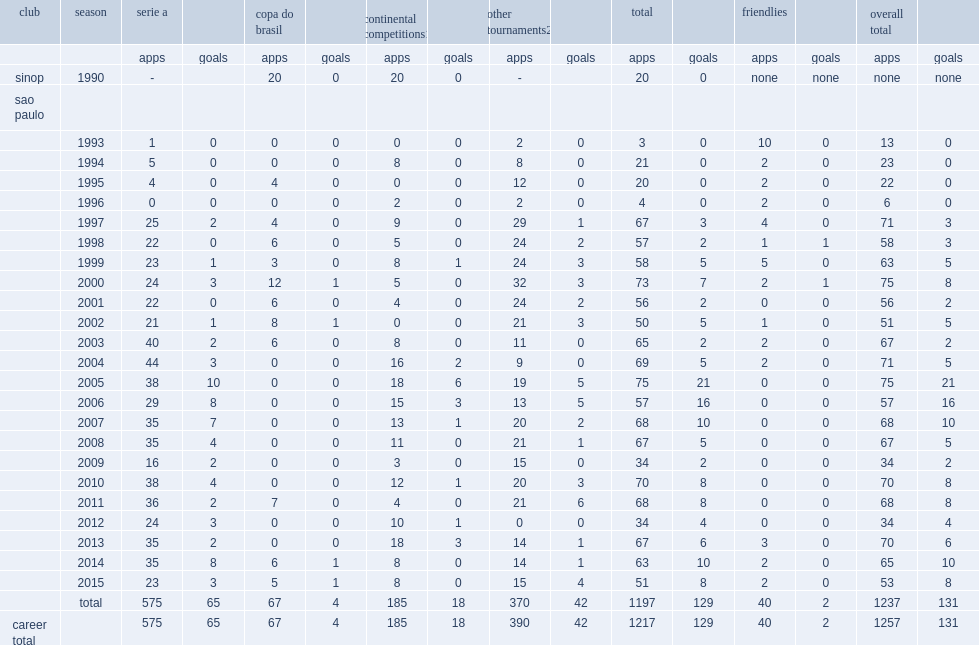How many goals did rogerio ceni score during his career? 131.0. 